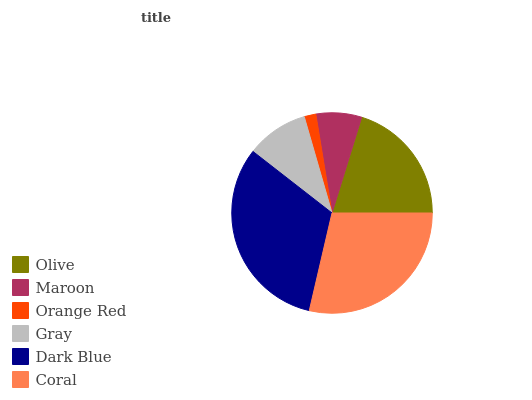Is Orange Red the minimum?
Answer yes or no. Yes. Is Dark Blue the maximum?
Answer yes or no. Yes. Is Maroon the minimum?
Answer yes or no. No. Is Maroon the maximum?
Answer yes or no. No. Is Olive greater than Maroon?
Answer yes or no. Yes. Is Maroon less than Olive?
Answer yes or no. Yes. Is Maroon greater than Olive?
Answer yes or no. No. Is Olive less than Maroon?
Answer yes or no. No. Is Olive the high median?
Answer yes or no. Yes. Is Gray the low median?
Answer yes or no. Yes. Is Coral the high median?
Answer yes or no. No. Is Maroon the low median?
Answer yes or no. No. 